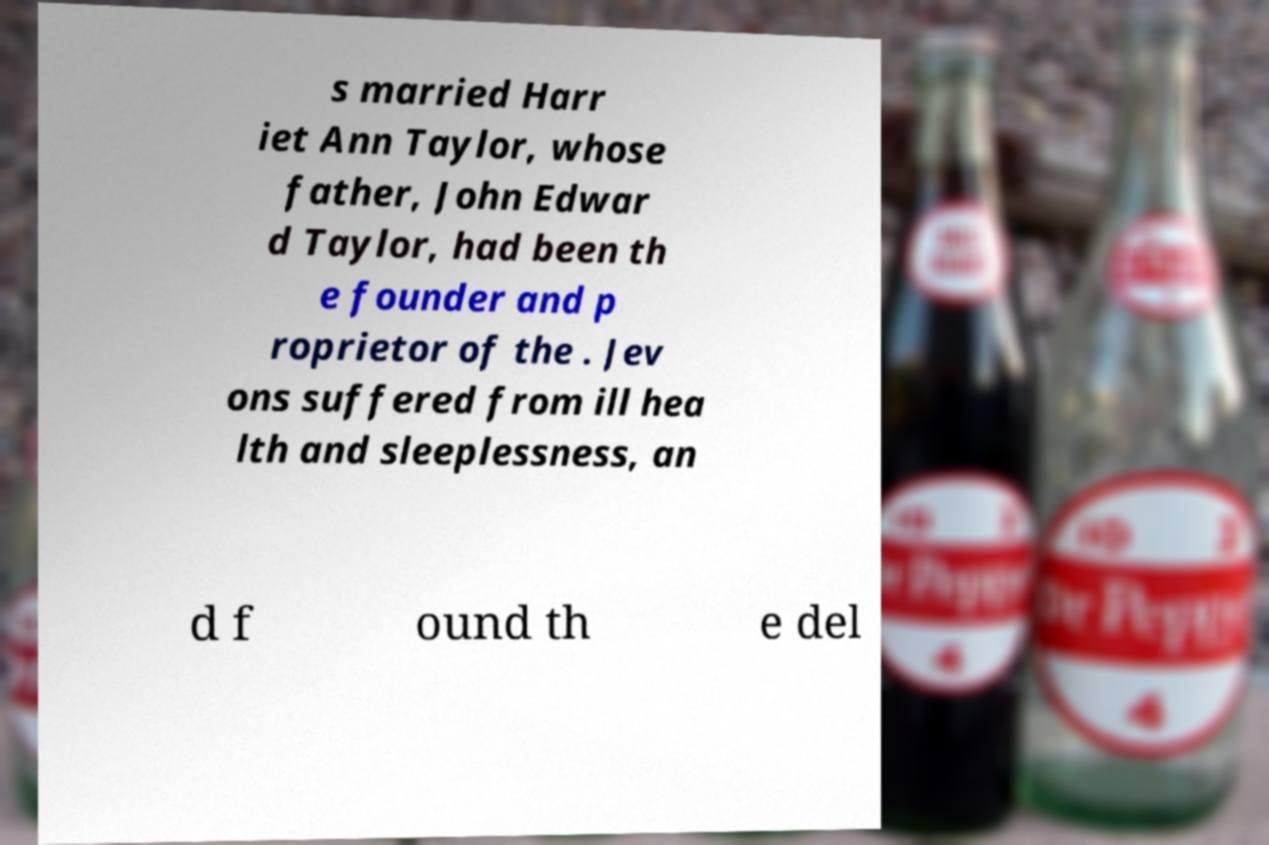Could you assist in decoding the text presented in this image and type it out clearly? s married Harr iet Ann Taylor, whose father, John Edwar d Taylor, had been th e founder and p roprietor of the . Jev ons suffered from ill hea lth and sleeplessness, an d f ound th e del 